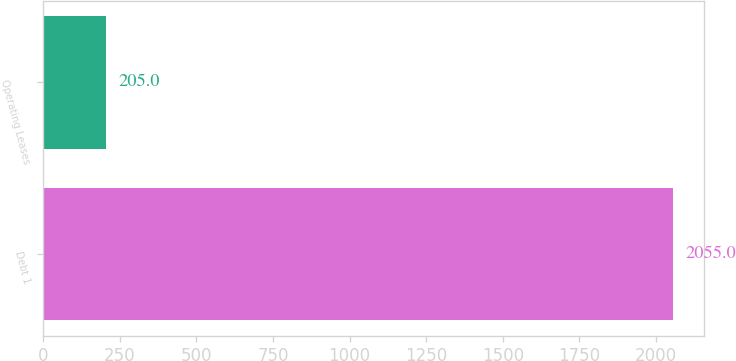<chart> <loc_0><loc_0><loc_500><loc_500><bar_chart><fcel>Debt 1<fcel>Operating Leases<nl><fcel>2055<fcel>205<nl></chart> 